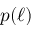Convert formula to latex. <formula><loc_0><loc_0><loc_500><loc_500>p ( \ell )</formula> 